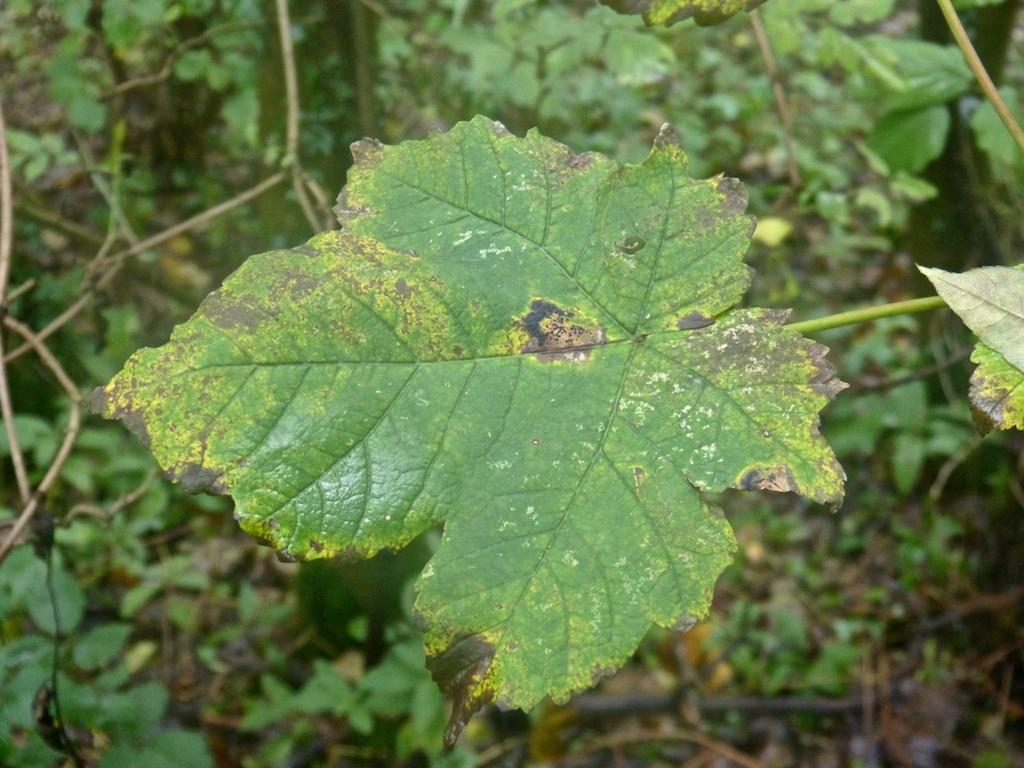What is the main subject of the image? The main subject of the image is a leaf. Can you describe the colors of the leaf? The leaf is green, yellow, and black in color. What can be seen in the background of the image? There are trees in the background of the image. What colors are the trees in the background? The trees in the background are green, brown, and black in color. Where is the badge located on the leaf in the image? There is no badge present on the leaf in the image. What type of nest can be seen in the image? There is no nest present in the image; it features a leaf and trees in the background. 